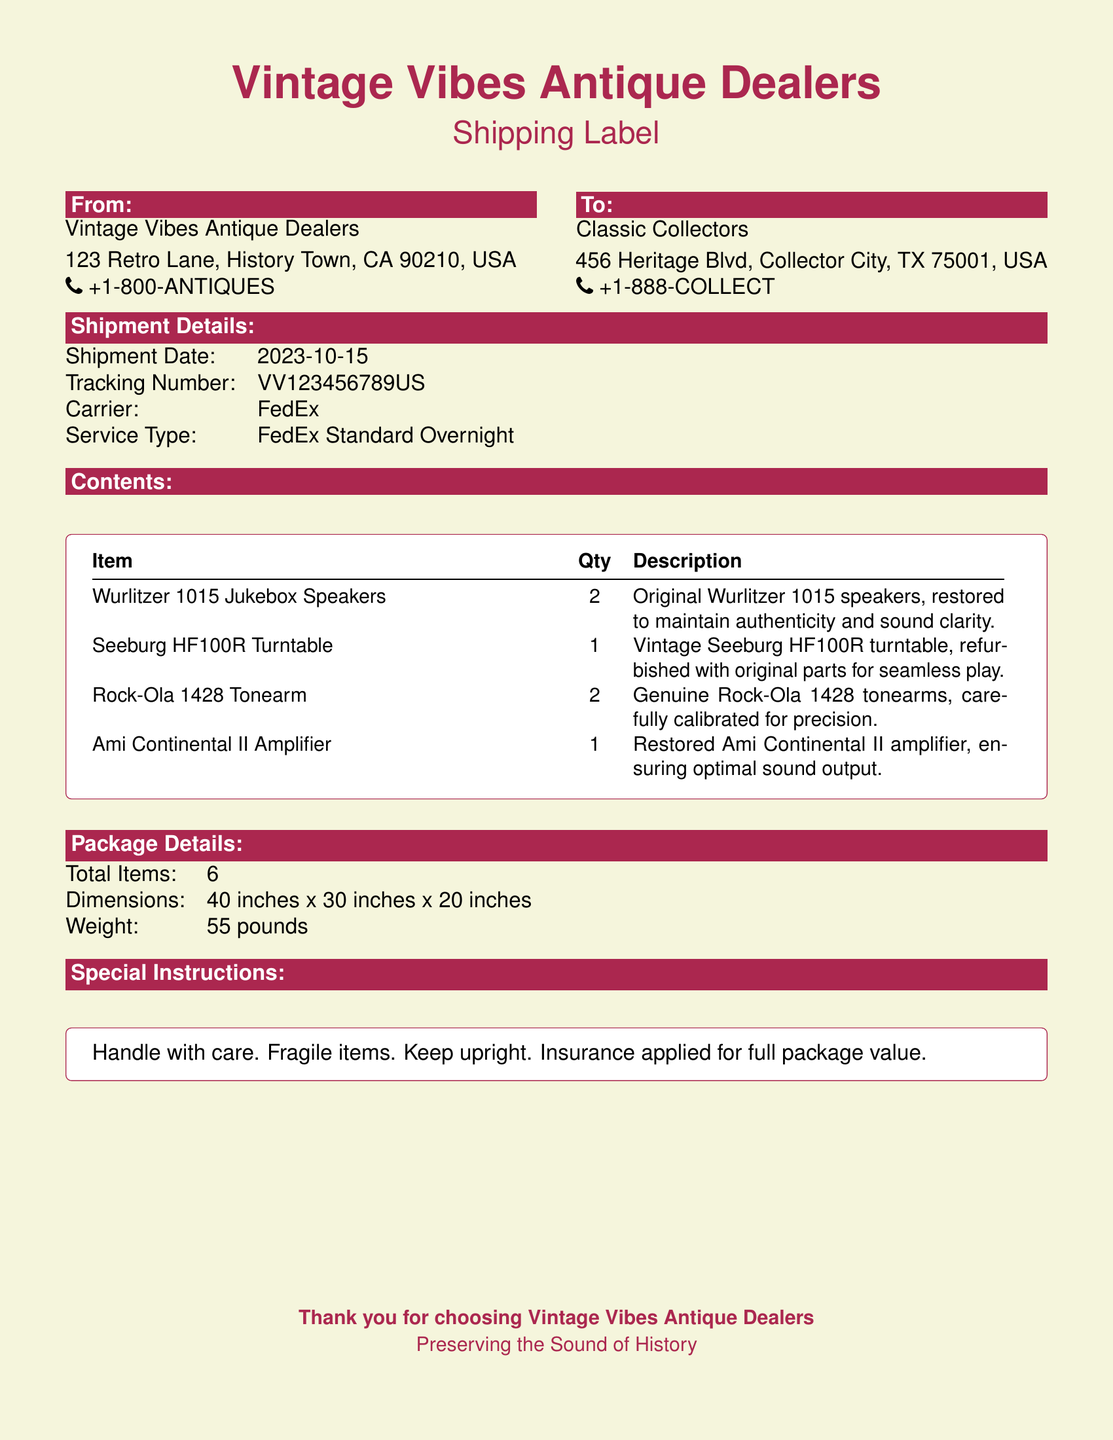What is the shipment date? The shipment date is stated in the document under "Shipment Details."
Answer: 2023-10-15 What is the total weight of the package? The total weight is listed in the "Package Details" section of the document.
Answer: 55 pounds Who is the sender? The name of the sender is provided in the "From" section of the label.
Answer: Vintage Vibes Antique Dealers How many original Wurlitzer 1015 speakers are included? The quantity of the Wurlitzer 1015 speakers is specified in the "Contents" section of the document.
Answer: 2 What is the tracking number? The tracking number is indicated in the "Shipment Details" section.
Answer: VV123456789US How many total items are being shipped? The total number of items is stated in the "Package Details" section.
Answer: 6 What special instructions are provided for handling? The special handling instructions are summarized in the "Special Instructions" section.
Answer: Handle with care. Fragile items. Keep upright What carrier is used for shipping? The carrier for the shipment is mentioned in the "Shipment Details" section.
Answer: FedEx What is the recipient's city? The recipient's city is specified in the "To" section of the label.
Answer: Collector City 